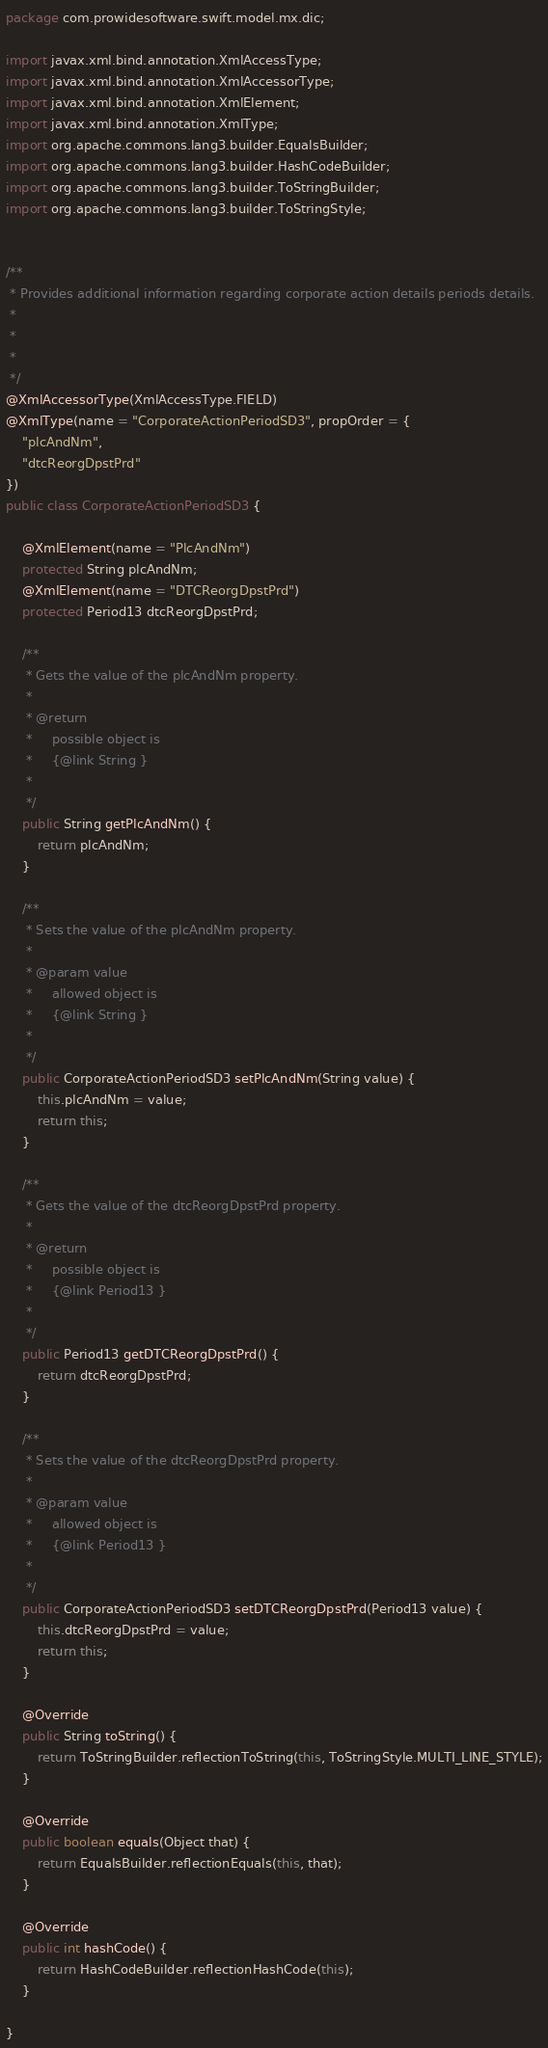Convert code to text. <code><loc_0><loc_0><loc_500><loc_500><_Java_>
package com.prowidesoftware.swift.model.mx.dic;

import javax.xml.bind.annotation.XmlAccessType;
import javax.xml.bind.annotation.XmlAccessorType;
import javax.xml.bind.annotation.XmlElement;
import javax.xml.bind.annotation.XmlType;
import org.apache.commons.lang3.builder.EqualsBuilder;
import org.apache.commons.lang3.builder.HashCodeBuilder;
import org.apache.commons.lang3.builder.ToStringBuilder;
import org.apache.commons.lang3.builder.ToStringStyle;


/**
 * Provides additional information regarding corporate action details periods details.
 * 
 * 
 * 
 */
@XmlAccessorType(XmlAccessType.FIELD)
@XmlType(name = "CorporateActionPeriodSD3", propOrder = {
    "plcAndNm",
    "dtcReorgDpstPrd"
})
public class CorporateActionPeriodSD3 {

    @XmlElement(name = "PlcAndNm")
    protected String plcAndNm;
    @XmlElement(name = "DTCReorgDpstPrd")
    protected Period13 dtcReorgDpstPrd;

    /**
     * Gets the value of the plcAndNm property.
     * 
     * @return
     *     possible object is
     *     {@link String }
     *     
     */
    public String getPlcAndNm() {
        return plcAndNm;
    }

    /**
     * Sets the value of the plcAndNm property.
     * 
     * @param value
     *     allowed object is
     *     {@link String }
     *     
     */
    public CorporateActionPeriodSD3 setPlcAndNm(String value) {
        this.plcAndNm = value;
        return this;
    }

    /**
     * Gets the value of the dtcReorgDpstPrd property.
     * 
     * @return
     *     possible object is
     *     {@link Period13 }
     *     
     */
    public Period13 getDTCReorgDpstPrd() {
        return dtcReorgDpstPrd;
    }

    /**
     * Sets the value of the dtcReorgDpstPrd property.
     * 
     * @param value
     *     allowed object is
     *     {@link Period13 }
     *     
     */
    public CorporateActionPeriodSD3 setDTCReorgDpstPrd(Period13 value) {
        this.dtcReorgDpstPrd = value;
        return this;
    }

    @Override
    public String toString() {
        return ToStringBuilder.reflectionToString(this, ToStringStyle.MULTI_LINE_STYLE);
    }

    @Override
    public boolean equals(Object that) {
        return EqualsBuilder.reflectionEquals(this, that);
    }

    @Override
    public int hashCode() {
        return HashCodeBuilder.reflectionHashCode(this);
    }

}
</code> 